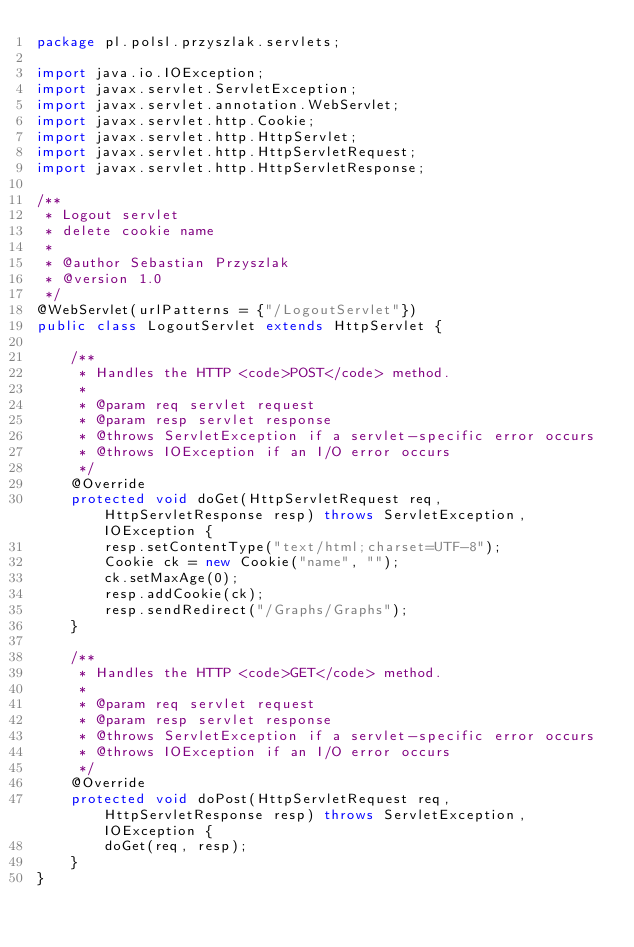Convert code to text. <code><loc_0><loc_0><loc_500><loc_500><_Java_>package pl.polsl.przyszlak.servlets;

import java.io.IOException;
import javax.servlet.ServletException;
import javax.servlet.annotation.WebServlet;
import javax.servlet.http.Cookie;
import javax.servlet.http.HttpServlet;
import javax.servlet.http.HttpServletRequest;
import javax.servlet.http.HttpServletResponse;

/**
 * Logout servlet
 * delete cookie name
 *
 * @author Sebastian Przyszlak
 * @version 1.0
 */
@WebServlet(urlPatterns = {"/LogoutServlet"})
public class LogoutServlet extends HttpServlet {

    /**
     * Handles the HTTP <code>POST</code> method.
     *
     * @param req servlet request
     * @param resp servlet response
     * @throws ServletException if a servlet-specific error occurs
     * @throws IOException if an I/O error occurs
     */
    @Override
    protected void doGet(HttpServletRequest req, HttpServletResponse resp) throws ServletException, IOException {
        resp.setContentType("text/html;charset=UTF-8");
        Cookie ck = new Cookie("name", "");
        ck.setMaxAge(0);
        resp.addCookie(ck);
        resp.sendRedirect("/Graphs/Graphs");
    }

    /**
     * Handles the HTTP <code>GET</code> method.
     *
     * @param req servlet request
     * @param resp servlet response
     * @throws ServletException if a servlet-specific error occurs
     * @throws IOException if an I/O error occurs
     */
    @Override
    protected void doPost(HttpServletRequest req, HttpServletResponse resp) throws ServletException, IOException {
        doGet(req, resp);
    }
}
</code> 